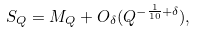Convert formula to latex. <formula><loc_0><loc_0><loc_500><loc_500>S _ { Q } = M _ { Q } + O _ { \delta } ( Q ^ { - \frac { 1 } { 1 0 } + \delta } ) ,</formula> 